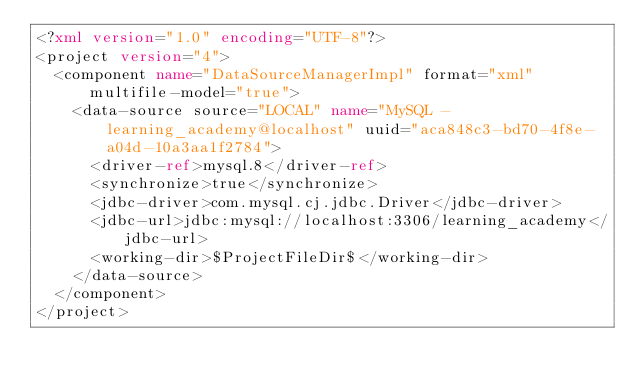Convert code to text. <code><loc_0><loc_0><loc_500><loc_500><_XML_><?xml version="1.0" encoding="UTF-8"?>
<project version="4">
  <component name="DataSourceManagerImpl" format="xml" multifile-model="true">
    <data-source source="LOCAL" name="MySQL - learning_academy@localhost" uuid="aca848c3-bd70-4f8e-a04d-10a3aa1f2784">
      <driver-ref>mysql.8</driver-ref>
      <synchronize>true</synchronize>
      <jdbc-driver>com.mysql.cj.jdbc.Driver</jdbc-driver>
      <jdbc-url>jdbc:mysql://localhost:3306/learning_academy</jdbc-url>
      <working-dir>$ProjectFileDir$</working-dir>
    </data-source>
  </component>
</project></code> 